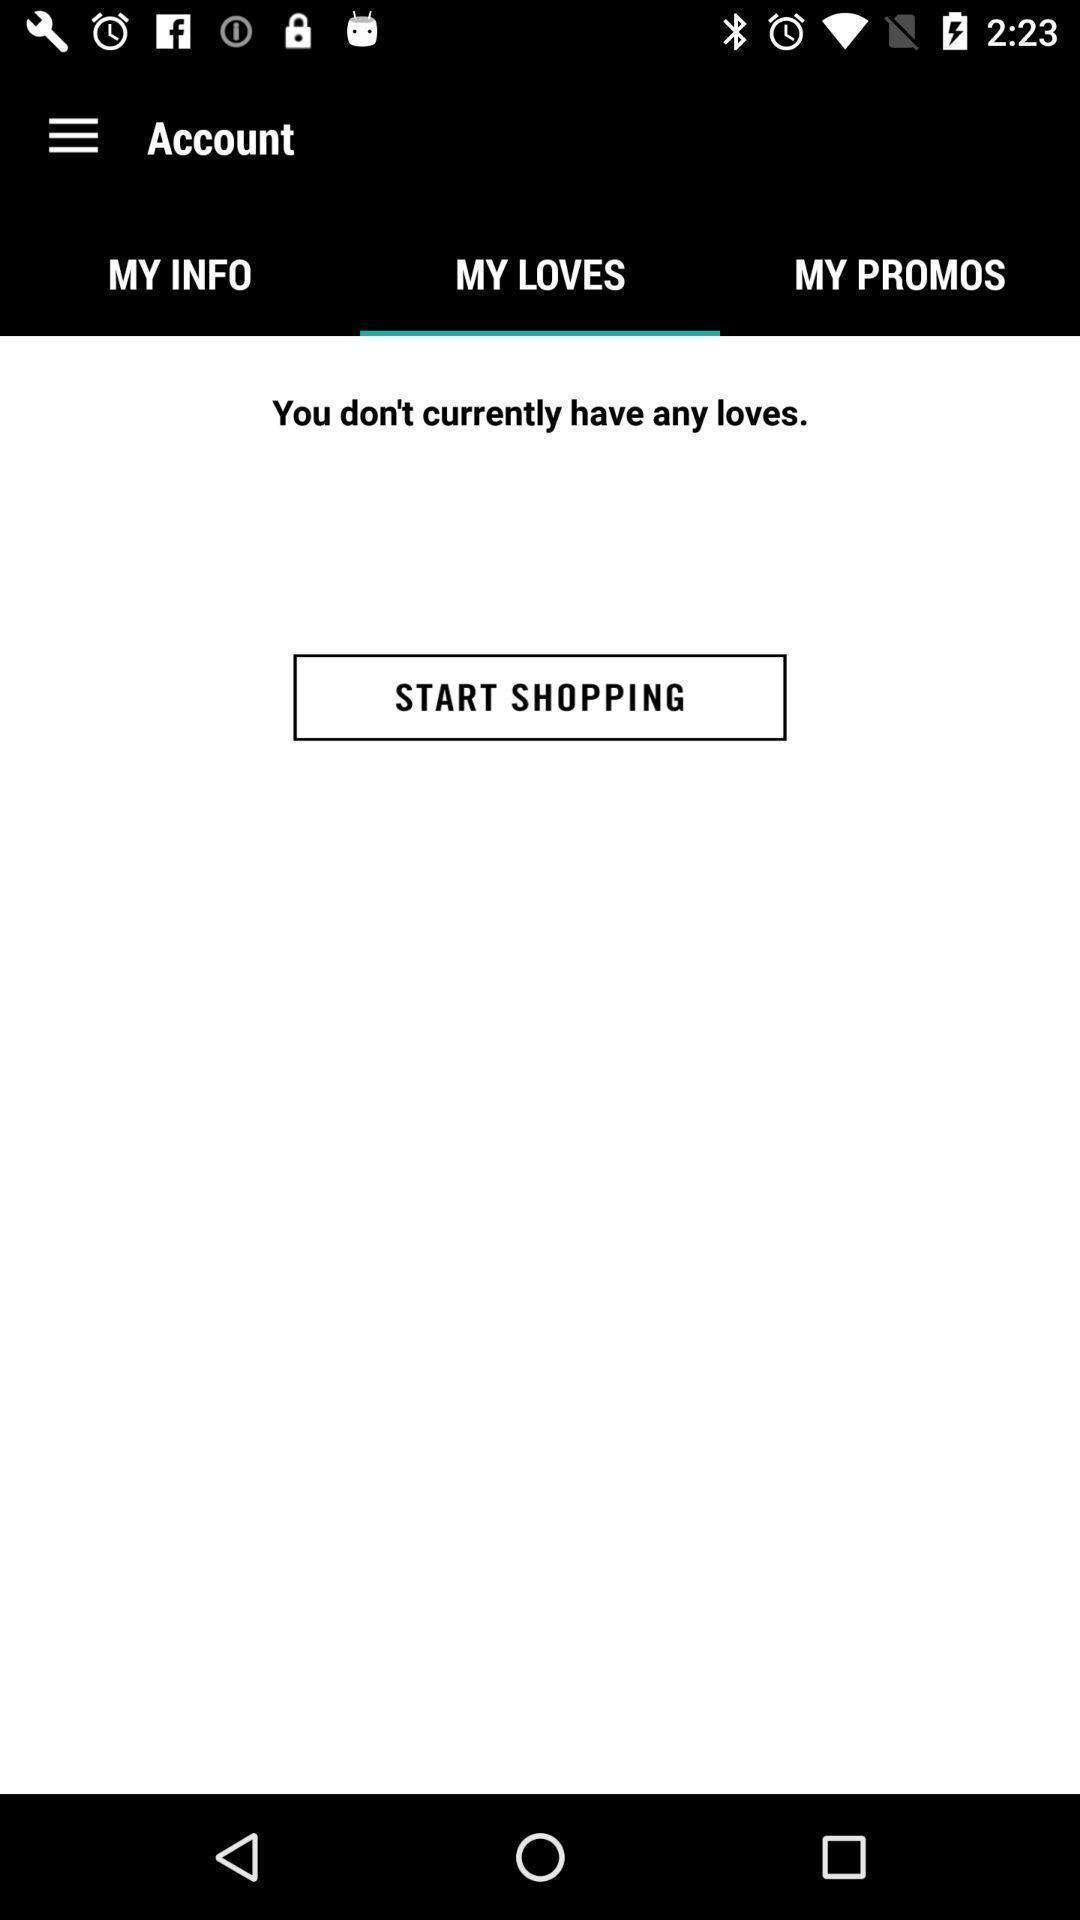Summarize the main components in this picture. Screen displaying the option to shop in my loves tab. 